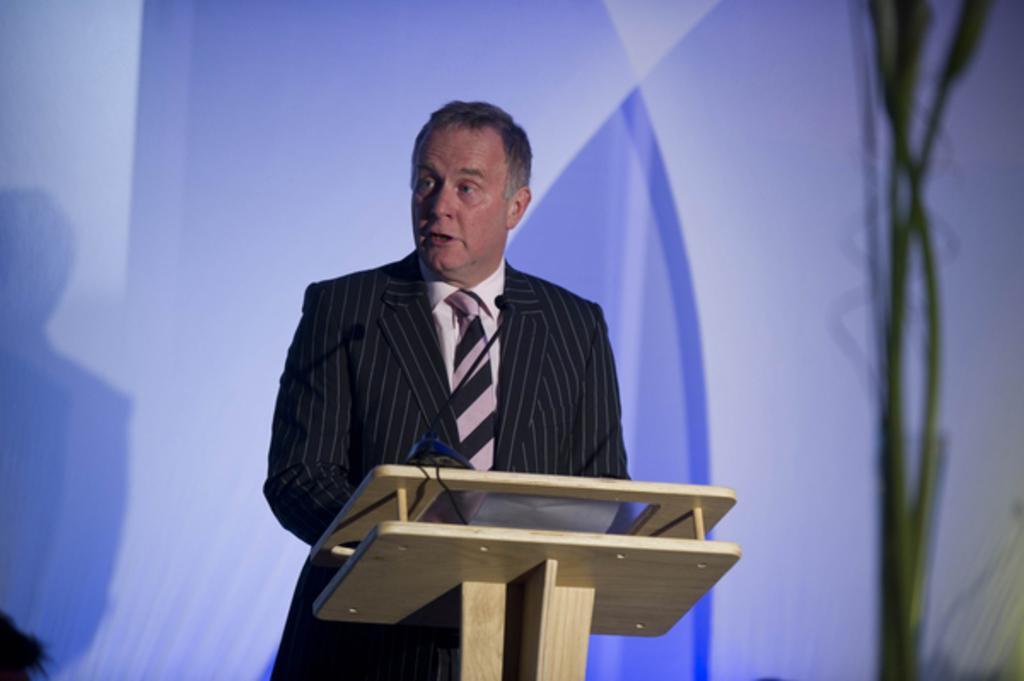How would you summarize this image in a sentence or two? This is the man standing. He wore a suit, shirt and tie. I think this is the wooden podium with the mike. The background looks light bluish in color. 